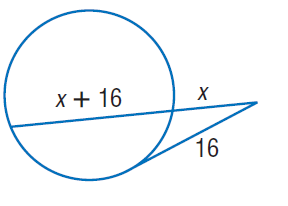Question: Find x. Round to the nearest tenth if necessary. Assume that segments that appear to be tangent are tangent.
Choices:
A. 8
B. 16
C. 24
D. 32
Answer with the letter. Answer: A 